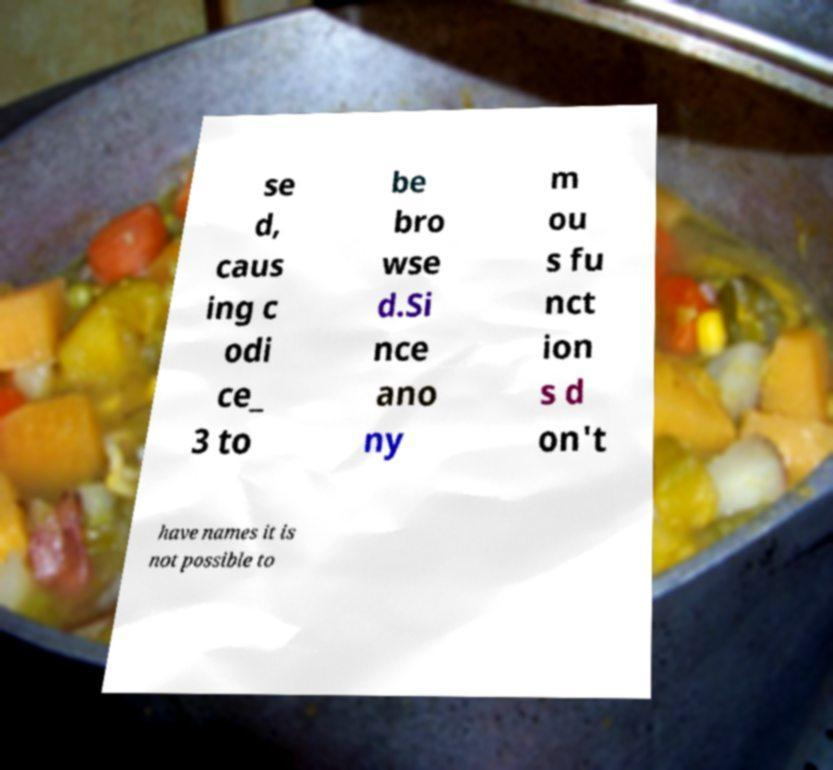Please read and relay the text visible in this image. What does it say? se d, caus ing c odi ce_ 3 to be bro wse d.Si nce ano ny m ou s fu nct ion s d on't have names it is not possible to 